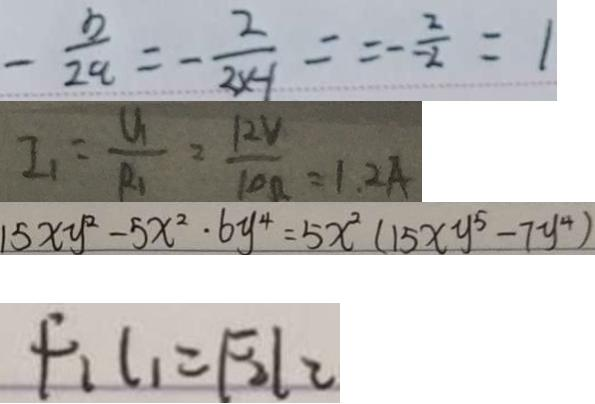Convert formula to latex. <formula><loc_0><loc_0><loc_500><loc_500>- \frac { b } { 2 a } = - \frac { 2 } { 2 x - 1 } = - \frac { 2 } { - 2 } = 1 
 I _ { 1 } = \frac { U _ { 1 } } { R _ { 1 } } = \frac { 1 2 V } { 1 0 \Omega } = 1 . 2 A 
 1 5 x y ^ { 2 } - 5 x ^ { 2 } \cdot 6 y ^ { 4 } = 5 x ^ { 2 } ( 1 5 x y ^ { 5 } - 7 y ^ { 4 } ) 
 F _ { 1 } l _ { 1 } = F _ { 2 } l _ { 2 }</formula> 